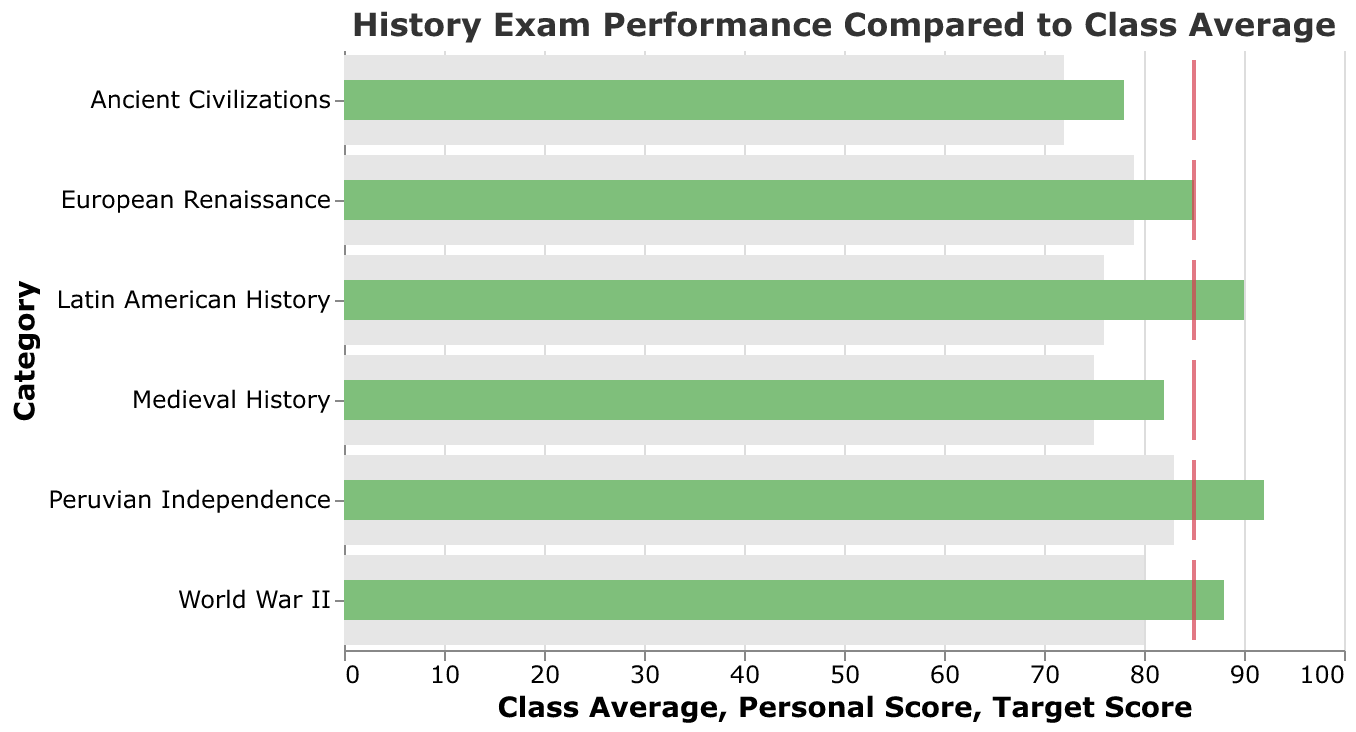What is the title of the chart? The title is clearly visible at the top of the chart. It reads, "History Exam Performance Compared to Class Average."
Answer: "History Exam Performance Compared to Class Average" What color represents the Personal Score bars? The bars representing Personal Scores are shown in green.
Answer: Green Which exam category has your highest personal score? By observing the top bar, we can see that the "Peruvian Independence" category has the highest personal score.
Answer: Peruvian Independence Did you meet or exceed your target score in any of the categories? By comparing the Personal Scores to the red tick marks for the Target Scores, we can see that none of the Personal Scores meet or exceed the Target Score of 85.
Answer: No 